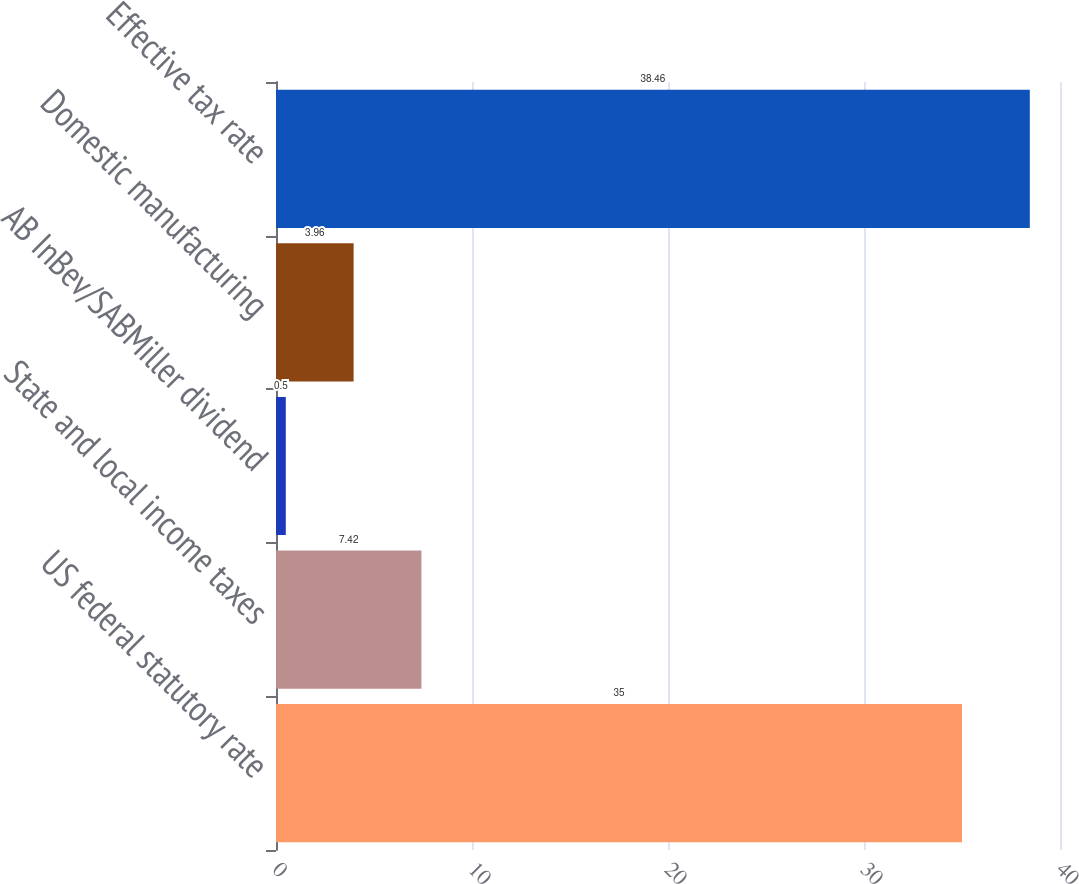Convert chart. <chart><loc_0><loc_0><loc_500><loc_500><bar_chart><fcel>US federal statutory rate<fcel>State and local income taxes<fcel>AB InBev/SABMiller dividend<fcel>Domestic manufacturing<fcel>Effective tax rate<nl><fcel>35<fcel>7.42<fcel>0.5<fcel>3.96<fcel>38.46<nl></chart> 